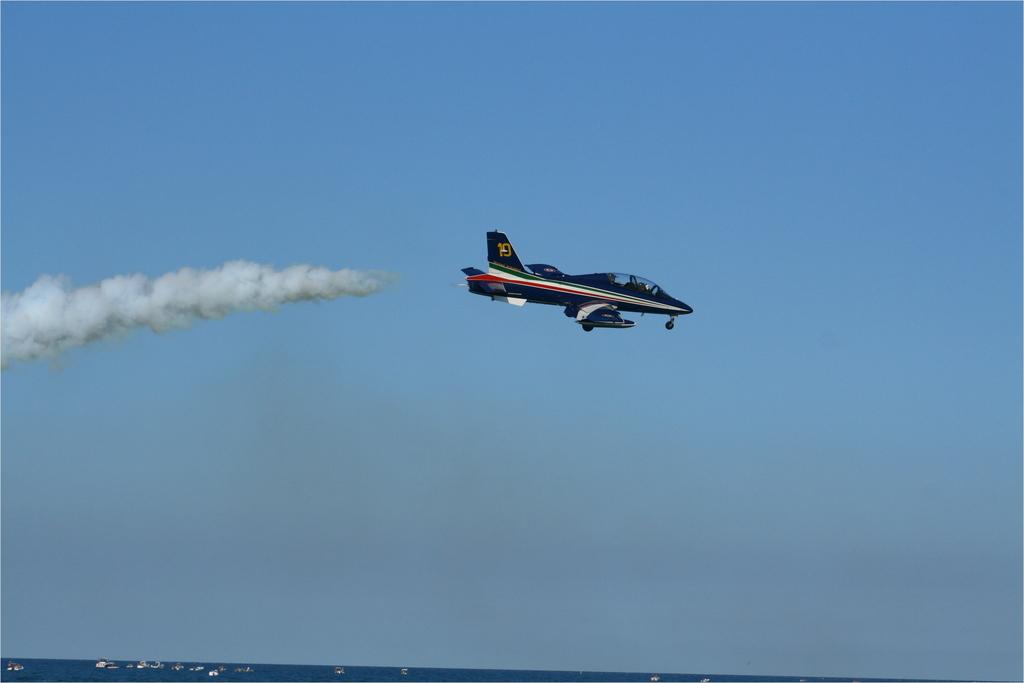What number is the plane?
Keep it short and to the point. 19. 